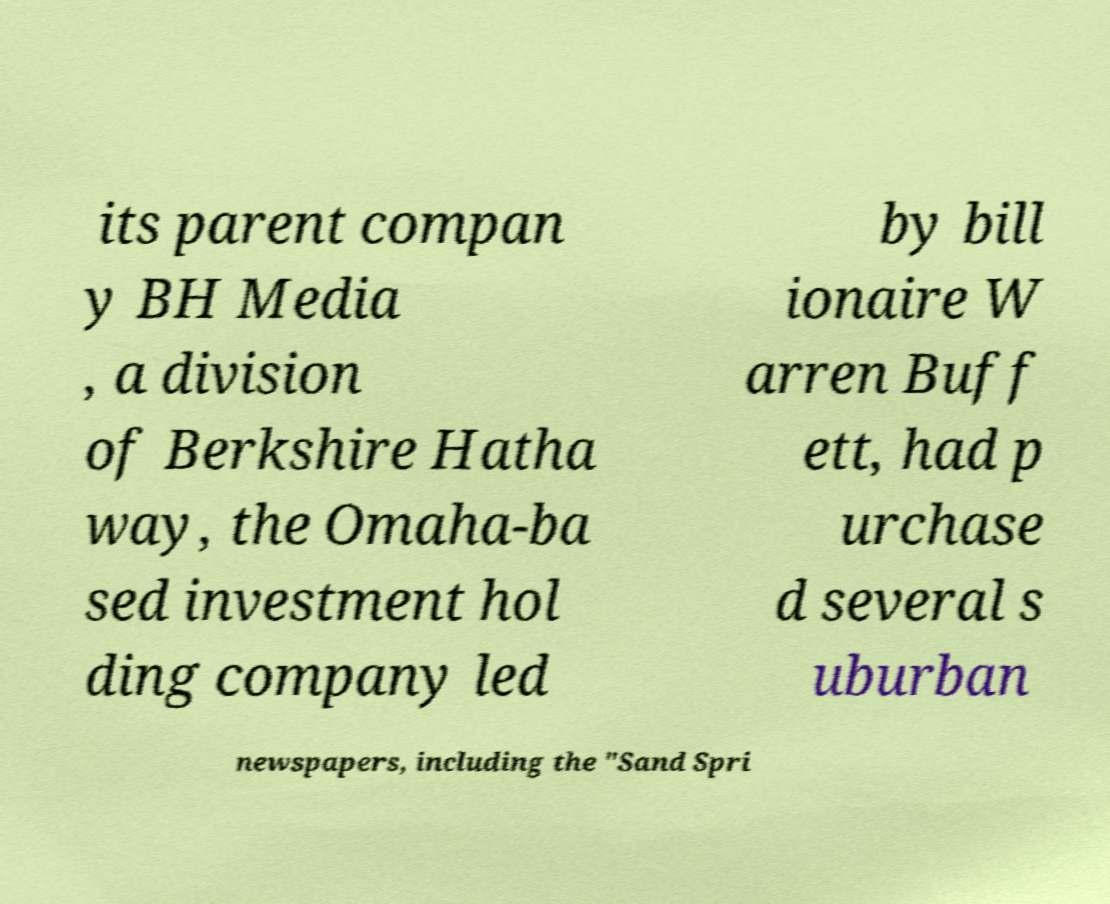There's text embedded in this image that I need extracted. Can you transcribe it verbatim? its parent compan y BH Media , a division of Berkshire Hatha way, the Omaha-ba sed investment hol ding company led by bill ionaire W arren Buff ett, had p urchase d several s uburban newspapers, including the "Sand Spri 